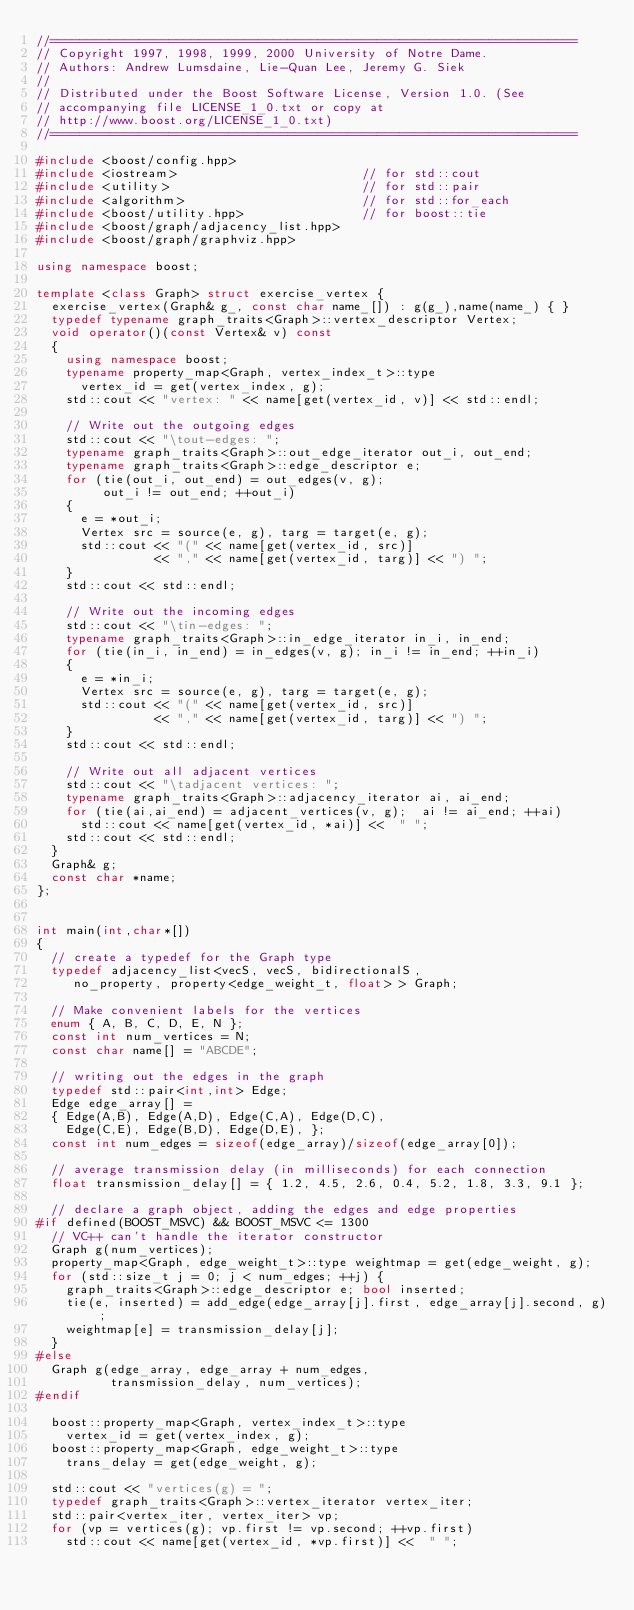<code> <loc_0><loc_0><loc_500><loc_500><_C++_>//=======================================================================
// Copyright 1997, 1998, 1999, 2000 University of Notre Dame.
// Authors: Andrew Lumsdaine, Lie-Quan Lee, Jeremy G. Siek
//
// Distributed under the Boost Software License, Version 1.0. (See
// accompanying file LICENSE_1_0.txt or copy at
// http://www.boost.org/LICENSE_1_0.txt)
//=======================================================================

#include <boost/config.hpp>
#include <iostream>                         // for std::cout
#include <utility>                          // for std::pair
#include <algorithm>                        // for std::for_each
#include <boost/utility.hpp>                // for boost::tie
#include <boost/graph/adjacency_list.hpp>
#include <boost/graph/graphviz.hpp>

using namespace boost;

template <class Graph> struct exercise_vertex {
  exercise_vertex(Graph& g_, const char name_[]) : g(g_),name(name_) { }
  typedef typename graph_traits<Graph>::vertex_descriptor Vertex;
  void operator()(const Vertex& v) const
  {
    using namespace boost;
    typename property_map<Graph, vertex_index_t>::type
      vertex_id = get(vertex_index, g);
    std::cout << "vertex: " << name[get(vertex_id, v)] << std::endl;

    // Write out the outgoing edges
    std::cout << "\tout-edges: ";
    typename graph_traits<Graph>::out_edge_iterator out_i, out_end;
    typename graph_traits<Graph>::edge_descriptor e;
    for (tie(out_i, out_end) = out_edges(v, g);
         out_i != out_end; ++out_i)
    {
      e = *out_i;
      Vertex src = source(e, g), targ = target(e, g);
      std::cout << "(" << name[get(vertex_id, src)]
                << "," << name[get(vertex_id, targ)] << ") ";
    }
    std::cout << std::endl;

    // Write out the incoming edges
    std::cout << "\tin-edges: ";
    typename graph_traits<Graph>::in_edge_iterator in_i, in_end;
    for (tie(in_i, in_end) = in_edges(v, g); in_i != in_end; ++in_i)
    {
      e = *in_i;
      Vertex src = source(e, g), targ = target(e, g);
      std::cout << "(" << name[get(vertex_id, src)]
                << "," << name[get(vertex_id, targ)] << ") ";
    }
    std::cout << std::endl;

    // Write out all adjacent vertices
    std::cout << "\tadjacent vertices: ";
    typename graph_traits<Graph>::adjacency_iterator ai, ai_end;
    for (tie(ai,ai_end) = adjacent_vertices(v, g);  ai != ai_end; ++ai)
      std::cout << name[get(vertex_id, *ai)] <<  " ";
    std::cout << std::endl;
  }
  Graph& g;
  const char *name;
};


int main(int,char*[])
{
  // create a typedef for the Graph type
  typedef adjacency_list<vecS, vecS, bidirectionalS,
     no_property, property<edge_weight_t, float> > Graph;

  // Make convenient labels for the vertices
  enum { A, B, C, D, E, N };
  const int num_vertices = N;
  const char name[] = "ABCDE";

  // writing out the edges in the graph
  typedef std::pair<int,int> Edge;
  Edge edge_array[] =
  { Edge(A,B), Edge(A,D), Edge(C,A), Edge(D,C),
    Edge(C,E), Edge(B,D), Edge(D,E), };
  const int num_edges = sizeof(edge_array)/sizeof(edge_array[0]);

  // average transmission delay (in milliseconds) for each connection
  float transmission_delay[] = { 1.2, 4.5, 2.6, 0.4, 5.2, 1.8, 3.3, 9.1 };

  // declare a graph object, adding the edges and edge properties
#if defined(BOOST_MSVC) && BOOST_MSVC <= 1300
  // VC++ can't handle the iterator constructor
  Graph g(num_vertices);
  property_map<Graph, edge_weight_t>::type weightmap = get(edge_weight, g);
  for (std::size_t j = 0; j < num_edges; ++j) {
    graph_traits<Graph>::edge_descriptor e; bool inserted;
    tie(e, inserted) = add_edge(edge_array[j].first, edge_array[j].second, g);
    weightmap[e] = transmission_delay[j];
  }
#else
  Graph g(edge_array, edge_array + num_edges,
          transmission_delay, num_vertices);
#endif

  boost::property_map<Graph, vertex_index_t>::type
    vertex_id = get(vertex_index, g);
  boost::property_map<Graph, edge_weight_t>::type
    trans_delay = get(edge_weight, g);

  std::cout << "vertices(g) = ";
  typedef graph_traits<Graph>::vertex_iterator vertex_iter;
  std::pair<vertex_iter, vertex_iter> vp;
  for (vp = vertices(g); vp.first != vp.second; ++vp.first)
    std::cout << name[get(vertex_id, *vp.first)] <<  " ";</code> 